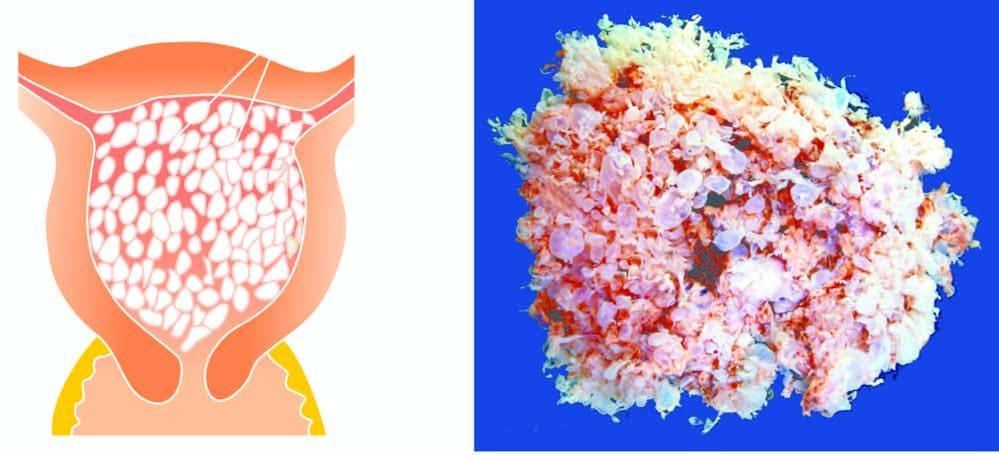re numbers in the illustrations also seen?
Answer the question using a single word or phrase. No 